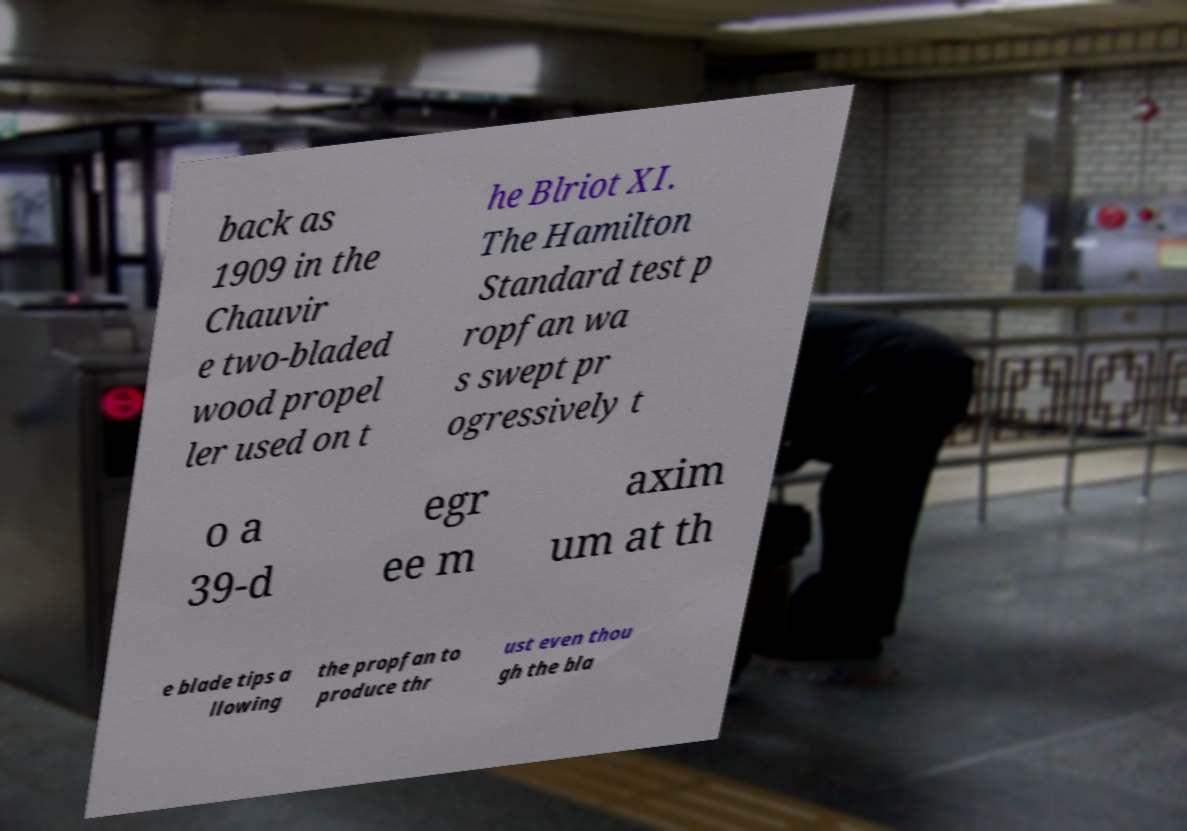For documentation purposes, I need the text within this image transcribed. Could you provide that? back as 1909 in the Chauvir e two-bladed wood propel ler used on t he Blriot XI. The Hamilton Standard test p ropfan wa s swept pr ogressively t o a 39-d egr ee m axim um at th e blade tips a llowing the propfan to produce thr ust even thou gh the bla 